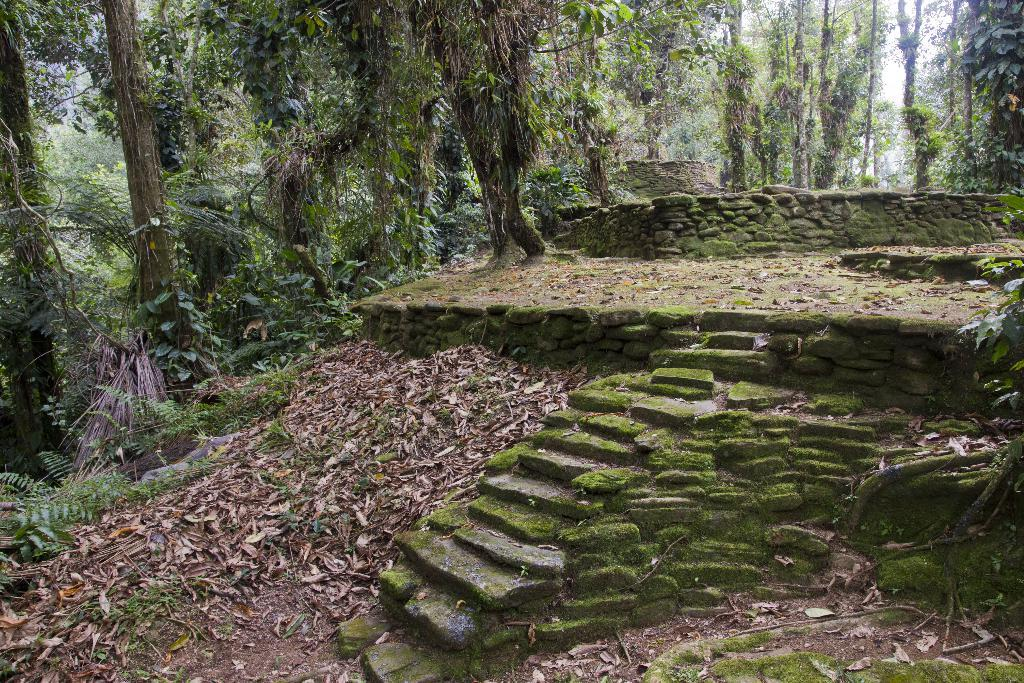What is the main structure in the image? There is a stage in the image. Are there any architectural features in the image? Yes, there are stairs in the image. What is covering the stage and the ground? Dry leaves are present on the stage and on the ground. What type of vegetation can be seen in the image? There are plants and trees in the image. What type of produce is hanging from the trees in the image? There is no produce visible in the image; only dry leaves and trees are present. Can you see any cobwebs in the image? There is no mention of cobwebs in the image, so it cannot be determined if they are present or not. 